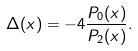Convert formula to latex. <formula><loc_0><loc_0><loc_500><loc_500>\Delta ( x ) = - 4 \frac { P _ { 0 } ( x ) } { P _ { 2 } ( x ) } .</formula> 